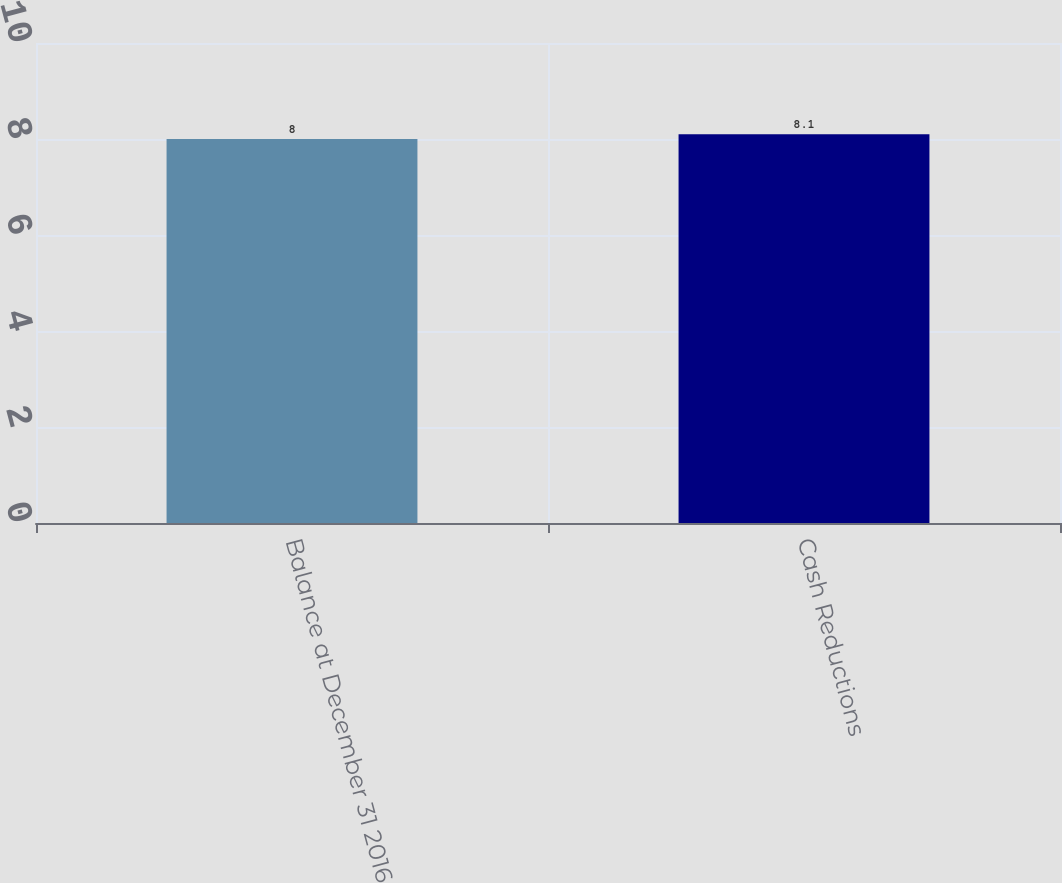Convert chart to OTSL. <chart><loc_0><loc_0><loc_500><loc_500><bar_chart><fcel>Balance at December 31 2016<fcel>Cash Reductions<nl><fcel>8<fcel>8.1<nl></chart> 